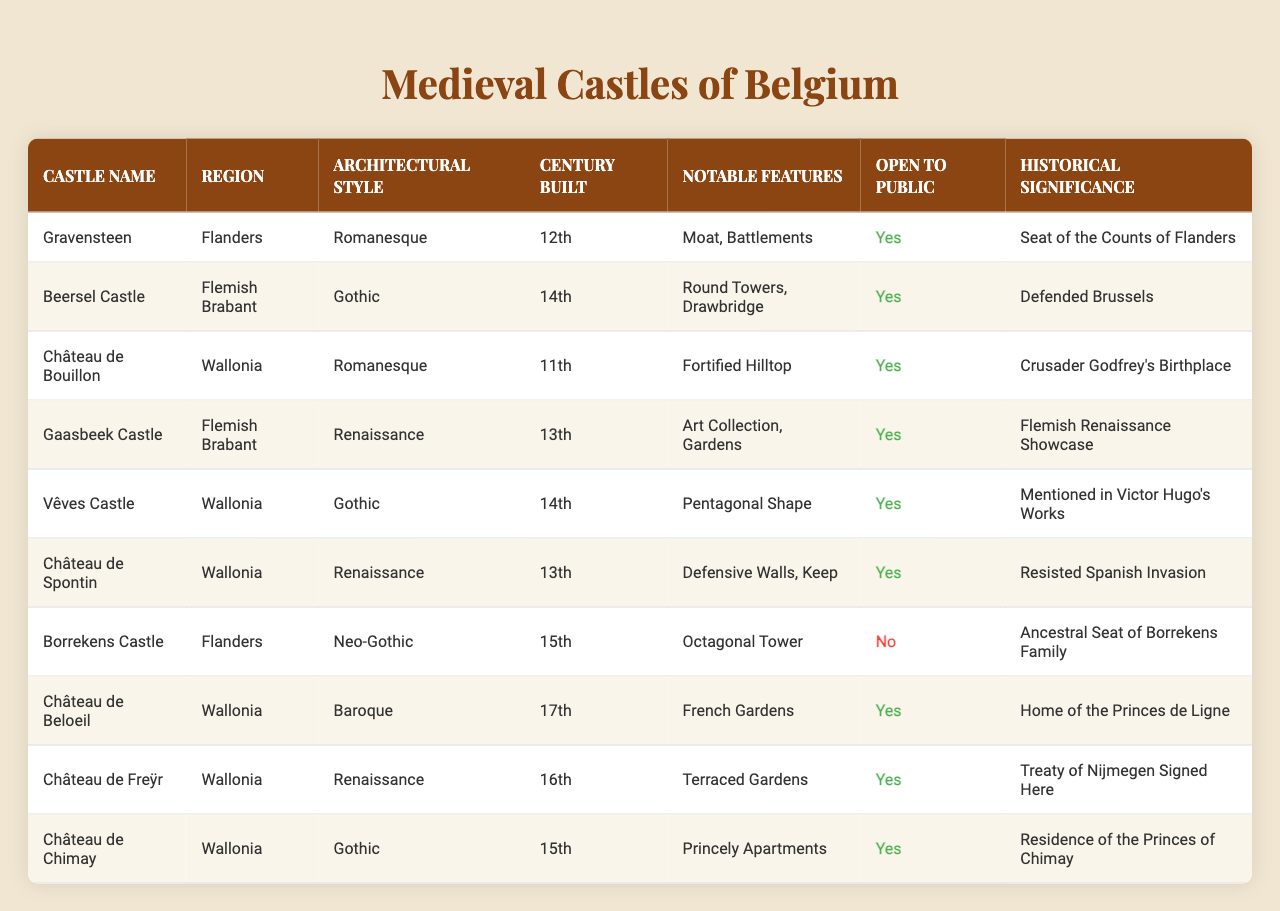What is the architectural style of Gravensteen? The table lists Gravensteen under the "Architectural Style" column, where it is shown to be a "Romanesque" style castle.
Answer: Romanesque How many castles are open to the public? By checking the "Open to Public" column, we see that there are 8 castles marked as "Yes", meaning they are accessible to the public.
Answer: 8 Which region has the most castles listed? By counting the occurrences of each region in the "Region" column, we find that Wallonia has 5 castles, which is more than any other region.
Answer: Wallonia What notable feature does Château de Freÿr have? In the "Notable Features" column, it mentions "Terraced Gardens" for Château de Freÿr.
Answer: Terraced Gardens Are there any castles built in the 12th century that are open to the public? Looking at the "Century Built" and "Open to Public" columns, Gravensteen is the only castle from the 12th century that is marked as open to the public.
Answer: Yes What is the average century built for the castles listed? Converting the centuries into numerical values (12th = 12, etc.) and averaging them (12 + 14 + 11 + 13 + 14 + 13 + 15 + 17 + 16 + 15) gives a total of  15, and dividing by 10 castles gives an average of 15.
Answer: 15 Which castle has the notable feature of a moat and battlements? By looking in the "Notable Features" column, these features are attributed to Gravensteen.
Answer: Gravensteen Is Château de Beloeil open to the public? In the "Open to Public" column, Château de Beloeil is marked "Yes", indicating it is open to visitors.
Answer: Yes What architectural styles are represented in Flemish Brabant? The architectural styles listed for the two castles in Flemish Brabant (Beersel Castle and Gaasbeek Castle) are Gothic and Renaissance respectively.
Answer: Gothic, Renaissance Which castles have defensive walls mentioned under notable features? By examining the "Notable Features" rows, both Château de Spontin and Beersel Castle mention "Defensive Walls," indicating that they feature such structures.
Answer: Château de Spontin, Beersel Castle What is the historical significance of Château de Chimay? The table specifies that Château de Chimay was the "Residence of the Princes of Chimay," indicating its historical importance.
Answer: Residence of the Princes of Chimay 